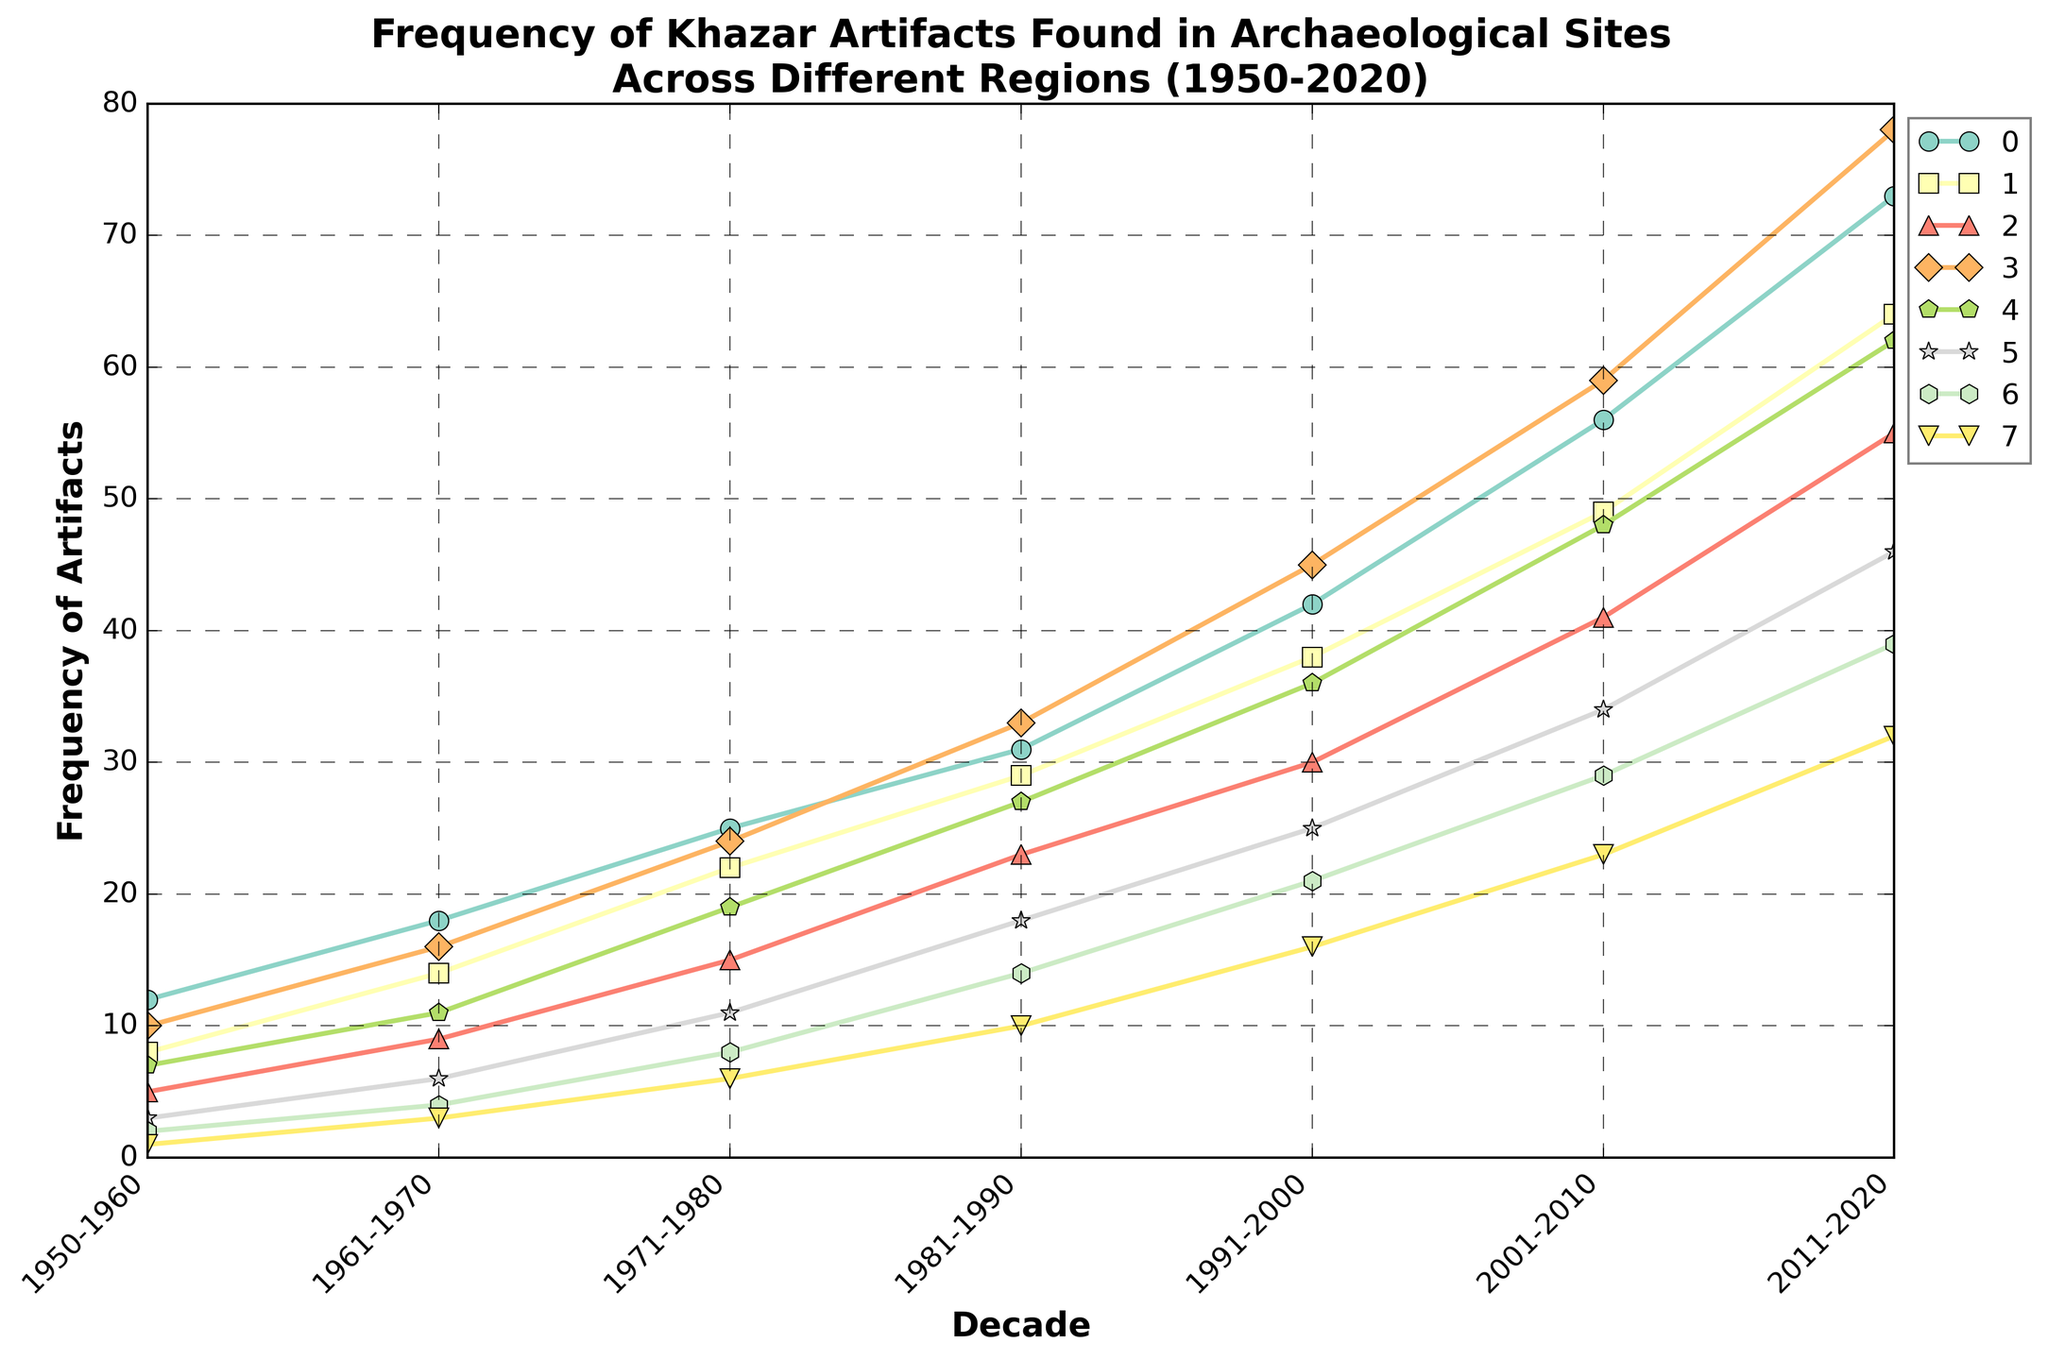Which region shows the highest increase in the frequency of artifacts from 1950-1960 to 2011-2020? Calculate the difference between the 2011-2020 and 1950-1960 values for each region. The region with the highest difference is the Volga Region (73 - 12 = 61).
Answer: Volga Region Which region had the least frequency of artifacts in the decade 2001-2010? Compare the 2001-2010 values for all regions and identify the smallest value. The region with the least frequency of artifacts is Georgia (23).
Answer: Georgia In which decade did the Don River Basin surpass the Volga Region in artifact frequency? Compare the data points of Volga Region and Don River Basin for each decade. The Don River Basin first surpasses the Volga Region in the 2011-2020 decade (78 vs 73).
Answer: 2011-2020 What is the combined frequency of artifacts found in the North Caucasus and Crimea regions for the decade 1971-1980? Sum the values for North Caucasus (22) and Crimea (15) for the decade 1971-1980. The combined frequency is 22 + 15 = 37.
Answer: 37 Which two regions had the closest frequency of artifacts in the decade 1991-2000? Find the absolute differences between artifact frequencies for each pair of regions in 1991-2000. The closest frequencies are Southern Ukraine (36) and North Caucasus (38), with a difference of 2.
Answer: Southern Ukraine and North Caucasus How many more artifacts were found in Azerbaijan compared to Georgia in the decade 2011-2020? Subtract Georgia's value (32) from Azerbaijan's value (39) for 2011-2020. The difference is 39 - 32 = 7.
Answer: 7 Which three regions had the highest frequencies of artifacts in the decade 2001-2010? Rank the regions by their 2001-2010 values and select the top three. The highest frequencies are Don River Basin (59), Volga Region (56), and North Caucasus (49).
Answer: Don River Basin, Volga Region, North Caucasus What is the average frequency of artifacts in Kazakhstan across the decades provided? Sum the frequencies for Kazakhstan across all decades (3+6+11+18+25+34+46) and divide by the number of decades (7). The average frequency is (3+6+11+18+25+34+46)/7 = 20.43 (approx).
Answer: 20.43 